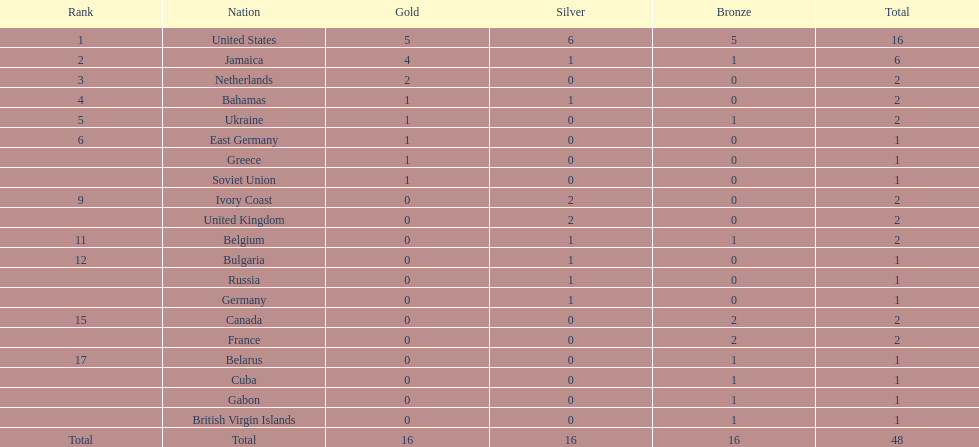Which countries won at least 3 silver medals? United States. 